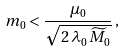<formula> <loc_0><loc_0><loc_500><loc_500>m _ { 0 } < \frac { \mu _ { 0 } } { \sqrt { 2 \, \lambda _ { 0 } \, { \widetilde { M } } _ { 0 } } } \, ,</formula> 